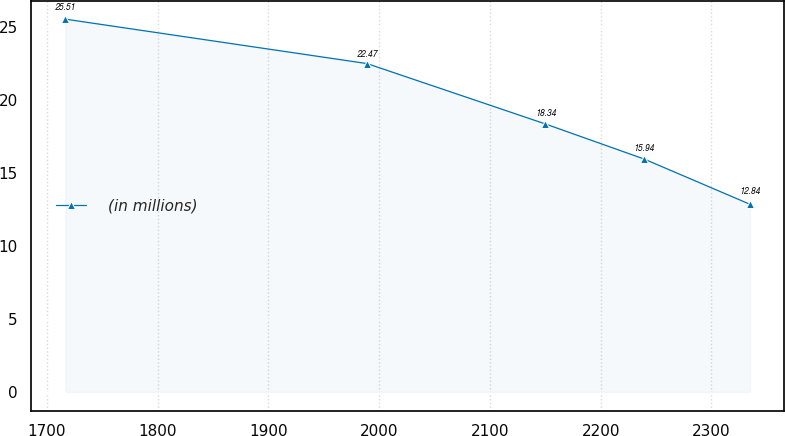Convert chart to OTSL. <chart><loc_0><loc_0><loc_500><loc_500><line_chart><ecel><fcel>(in millions)<nl><fcel>1716.75<fcel>25.51<nl><fcel>1989.05<fcel>22.47<nl><fcel>2150<fcel>18.34<nl><fcel>2239.12<fcel>15.94<nl><fcel>2334.79<fcel>12.84<nl></chart> 